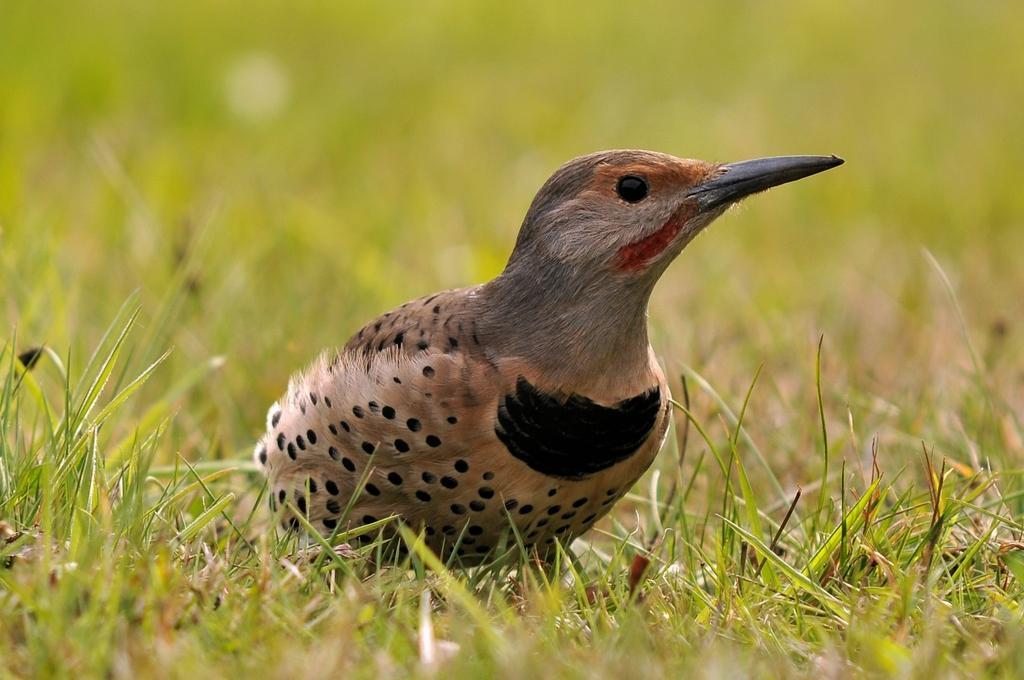Could you give a brief overview of what you see in this image? In this image we can see a bird on the grass. 